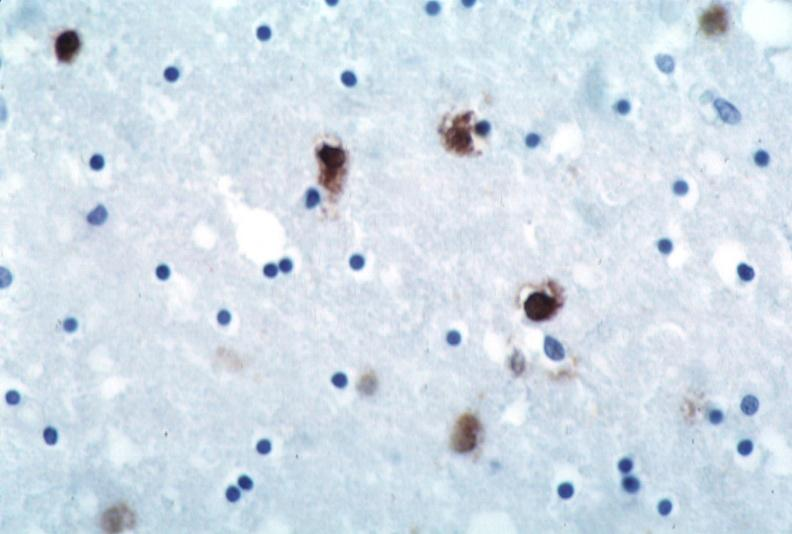s nervous present?
Answer the question using a single word or phrase. Yes 